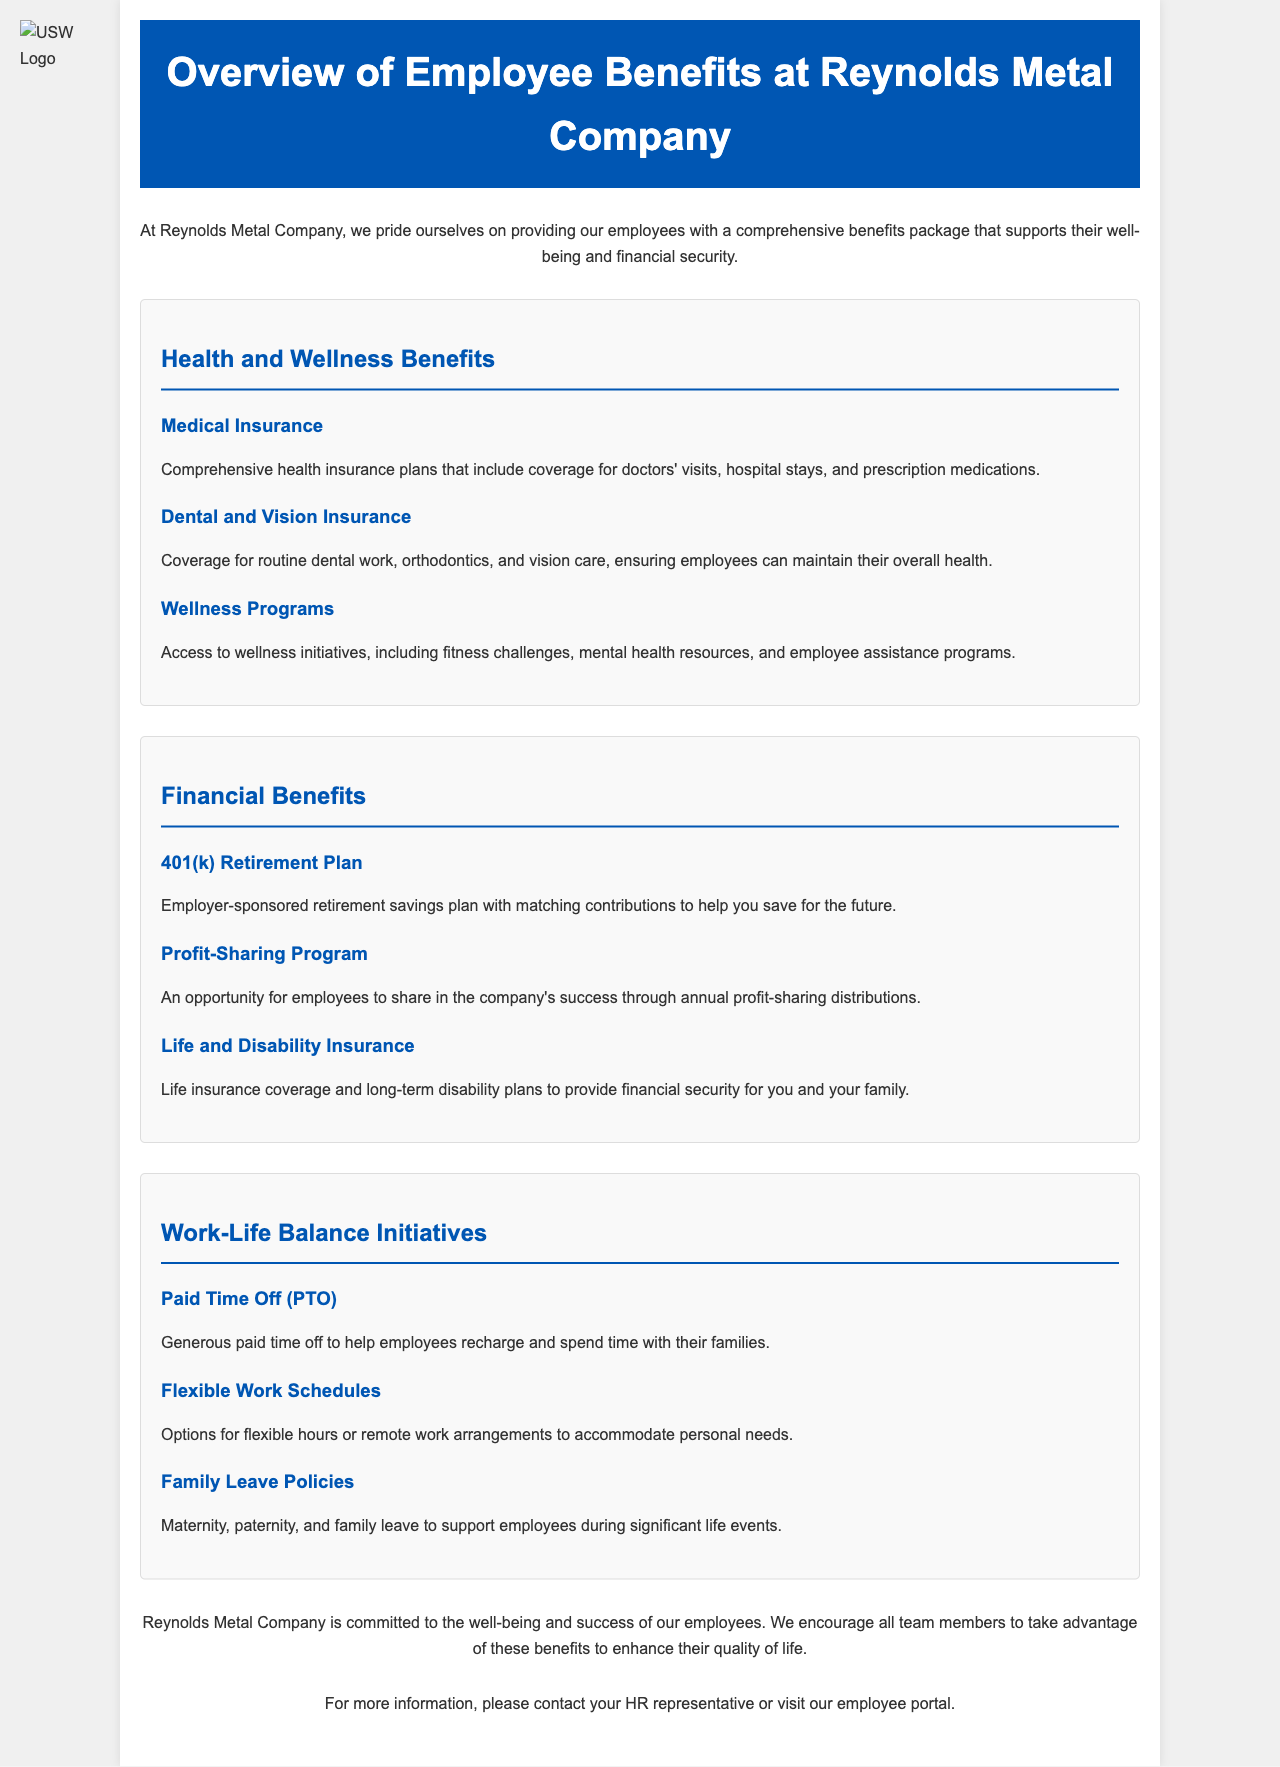what type of insurance covers doctor's visits? The document states that 'Medical Insurance' includes coverage for doctors' visits.
Answer: Medical Insurance what benefit program allows employees to save for retirement? The document mentions a '401(k) Retirement Plan' as a savings program for retirement.
Answer: 401(k) Retirement Plan which programs support employees’ health? The document lists 'Health and Wellness Benefits' as programs that support employees’ health.
Answer: Health and Wellness Benefits how many sections are there in the benefits overview? The document has three sections: Health and Wellness Benefits, Financial Benefits, and Work-Life Balance Initiatives.
Answer: Three what is offered under Family Leave Policies? The document specifies that Family Leave Policies include maternity and paternity leave for significant life events.
Answer: Maternity, paternity, and family leave what is the purpose of the Profit-Sharing Program? The document states that the Profit-Sharing Program offers employees an opportunity to share in the company's success.
Answer: Share in the company's success which program includes mental health resources? The document indicates that 'Wellness Programs' provide access to mental health resources.
Answer: Wellness Programs who should employees contact for more information about benefits? The document suggests contacting 'your HR representative' for more information about benefits.
Answer: Your HR representative what type of insurance is included for financial security? The document mentions 'Life and Disability Insurance' as types of insurance for financial security.
Answer: Life and Disability Insurance 